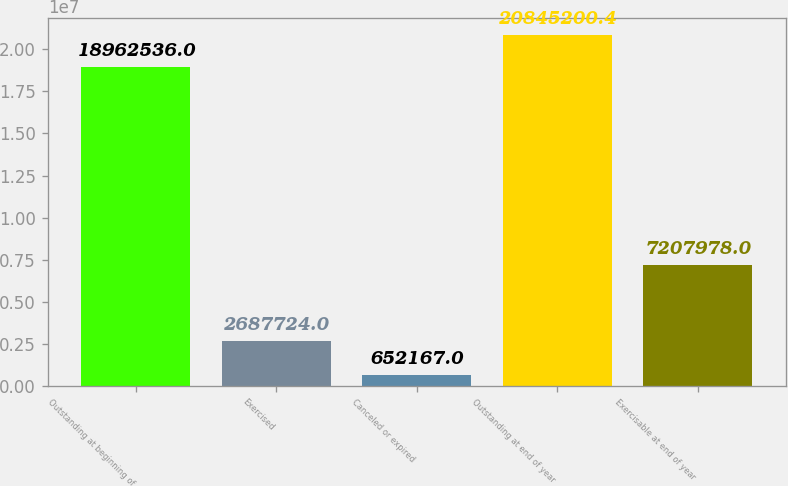<chart> <loc_0><loc_0><loc_500><loc_500><bar_chart><fcel>Outstanding at beginning of<fcel>Exercised<fcel>Canceled or expired<fcel>Outstanding at end of year<fcel>Exercisable at end of year<nl><fcel>1.89625e+07<fcel>2.68772e+06<fcel>652167<fcel>2.08452e+07<fcel>7.20798e+06<nl></chart> 